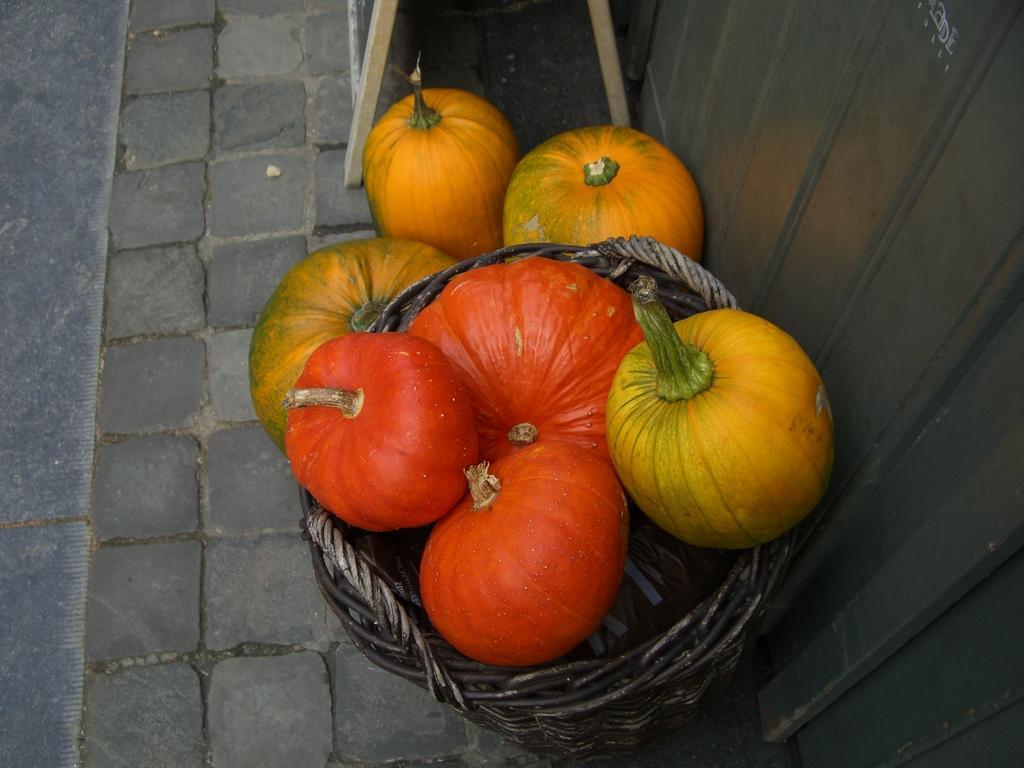Can you describe this image briefly? In the picture I can see pumpkins in a basket. I can also see some other objects. 